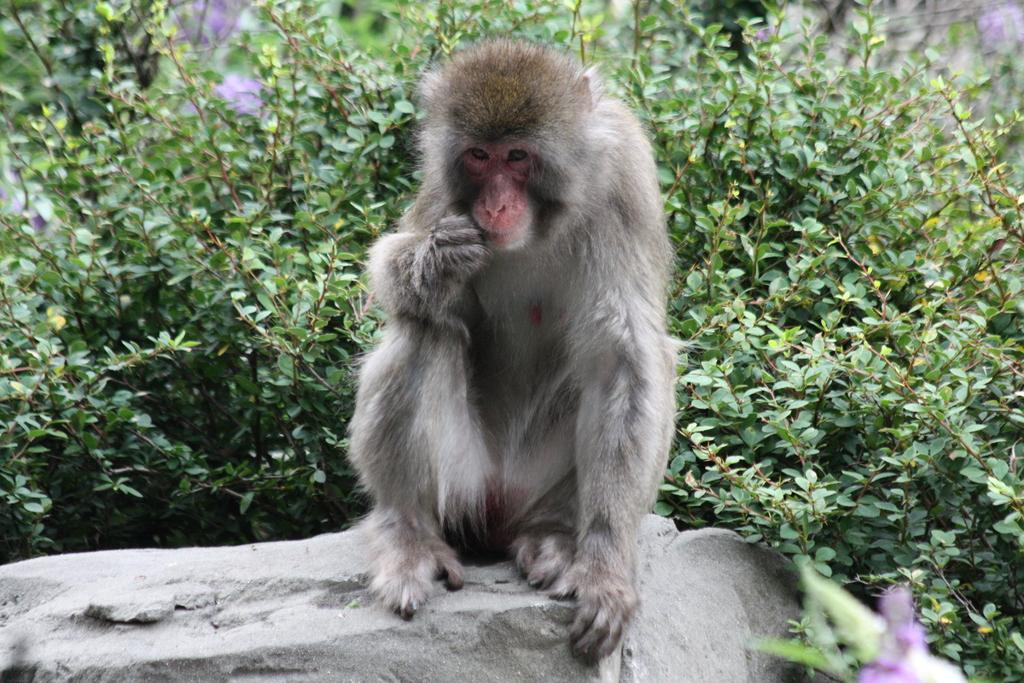What is the main subject in the foreground of the picture? There is a monkey in the foreground of the picture. Where is the monkey located? The monkey is on a rock. What can be seen in the background of the image? There are plants in the background of the image. What country is the monkey from in the image? The image does not provide information about the monkey's country of origin. 